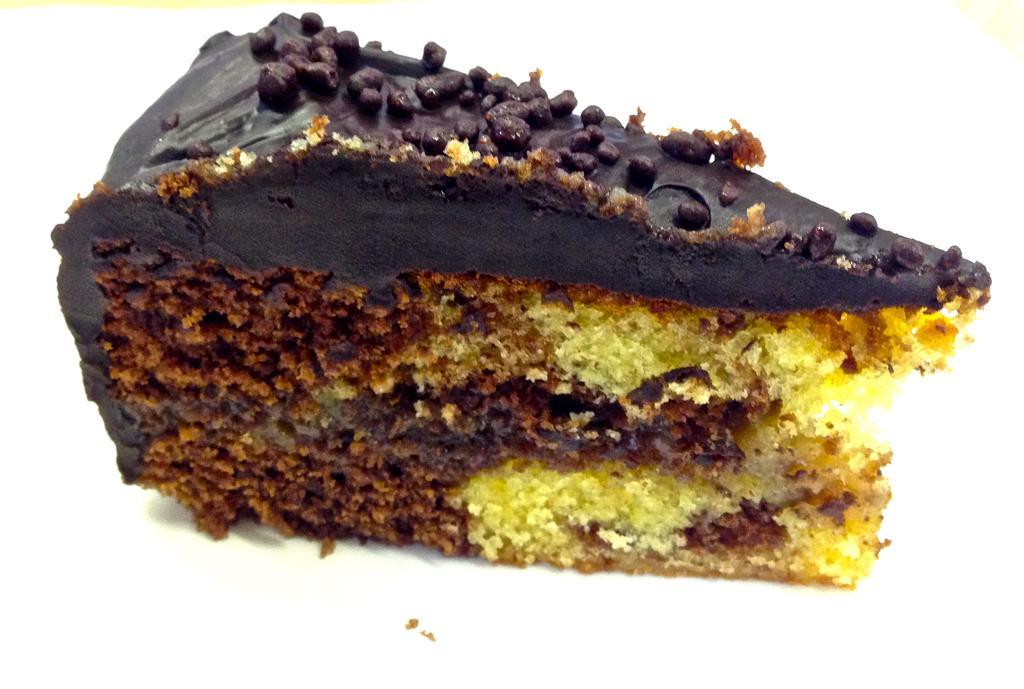Could you give a brief overview of what you see in this image? In this image we can see a food item, and the background is white in color. 